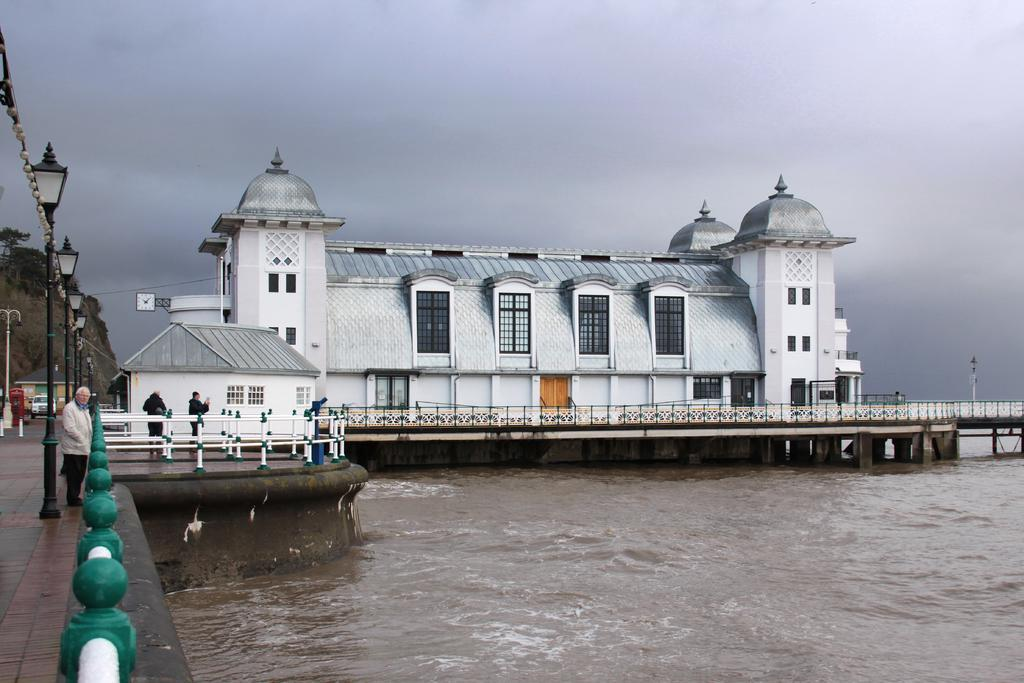What can be seen in the image? There are people standing in the image, along with a fence, water, a house, a building, lights on poles, trees, and the sky. Can you describe the fence in the image? Yes, there is a fence in the image. What is the background of the image like? The background of the image includes trees and the sky. How many structures can be seen in the image? There are two structures visible in the image: a house and a building. Are there any lighting features in the image? Yes, there are lights on poles in the image. What type of pot is being used to water the ground in the image? There is no pot or ground watering activity present in the image. What is the source of the surprise in the image? There is no surprise or any indication of a surprise in the image. 